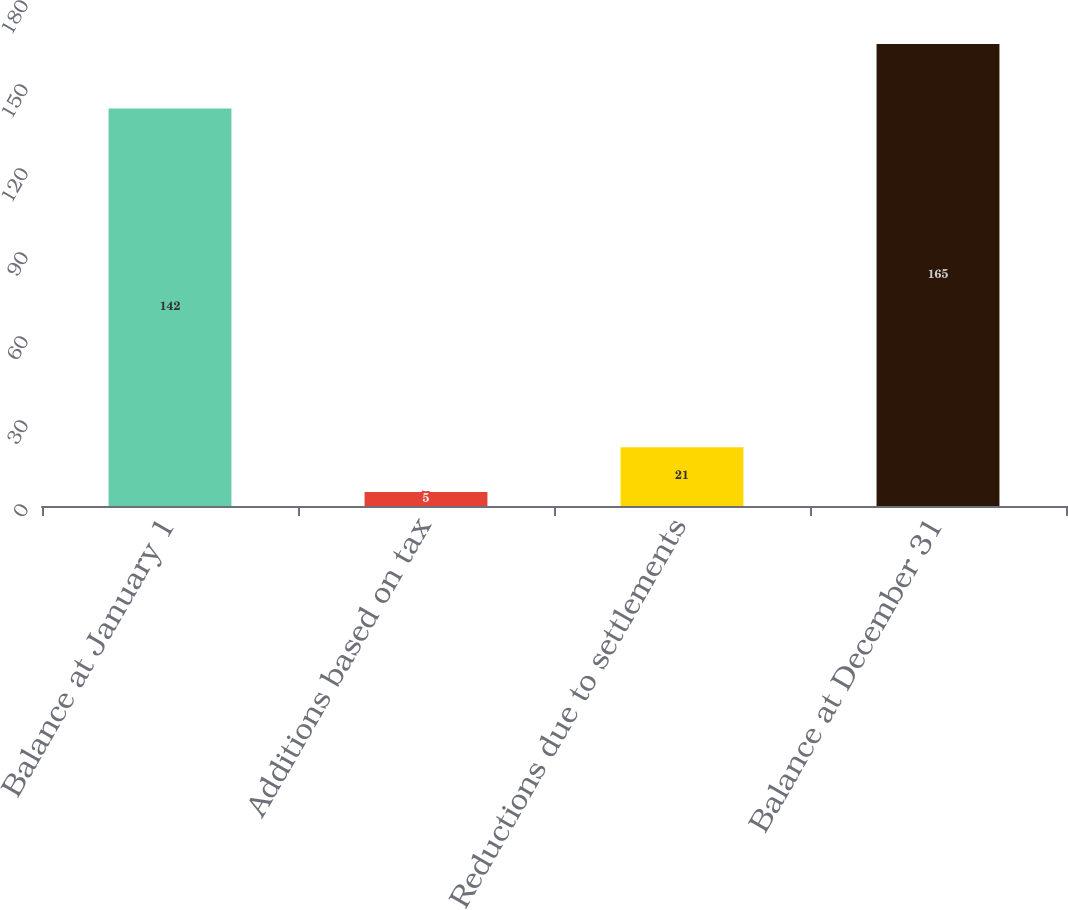Convert chart. <chart><loc_0><loc_0><loc_500><loc_500><bar_chart><fcel>Balance at January 1<fcel>Additions based on tax<fcel>Reductions due to settlements<fcel>Balance at December 31<nl><fcel>142<fcel>5<fcel>21<fcel>165<nl></chart> 